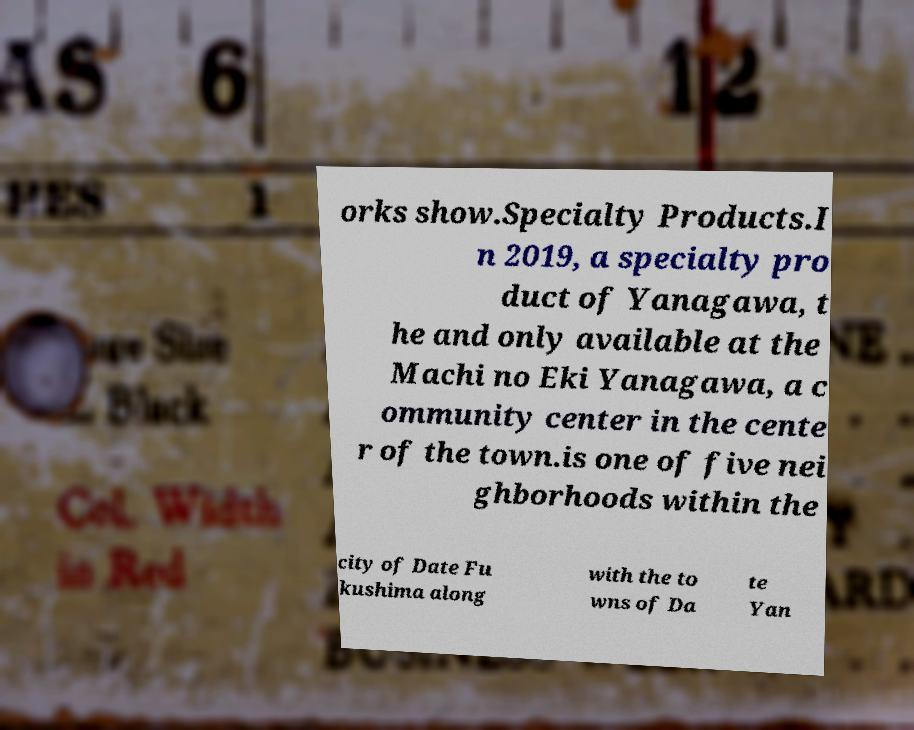I need the written content from this picture converted into text. Can you do that? orks show.Specialty Products.I n 2019, a specialty pro duct of Yanagawa, t he and only available at the Machi no Eki Yanagawa, a c ommunity center in the cente r of the town.is one of five nei ghborhoods within the city of Date Fu kushima along with the to wns of Da te Yan 